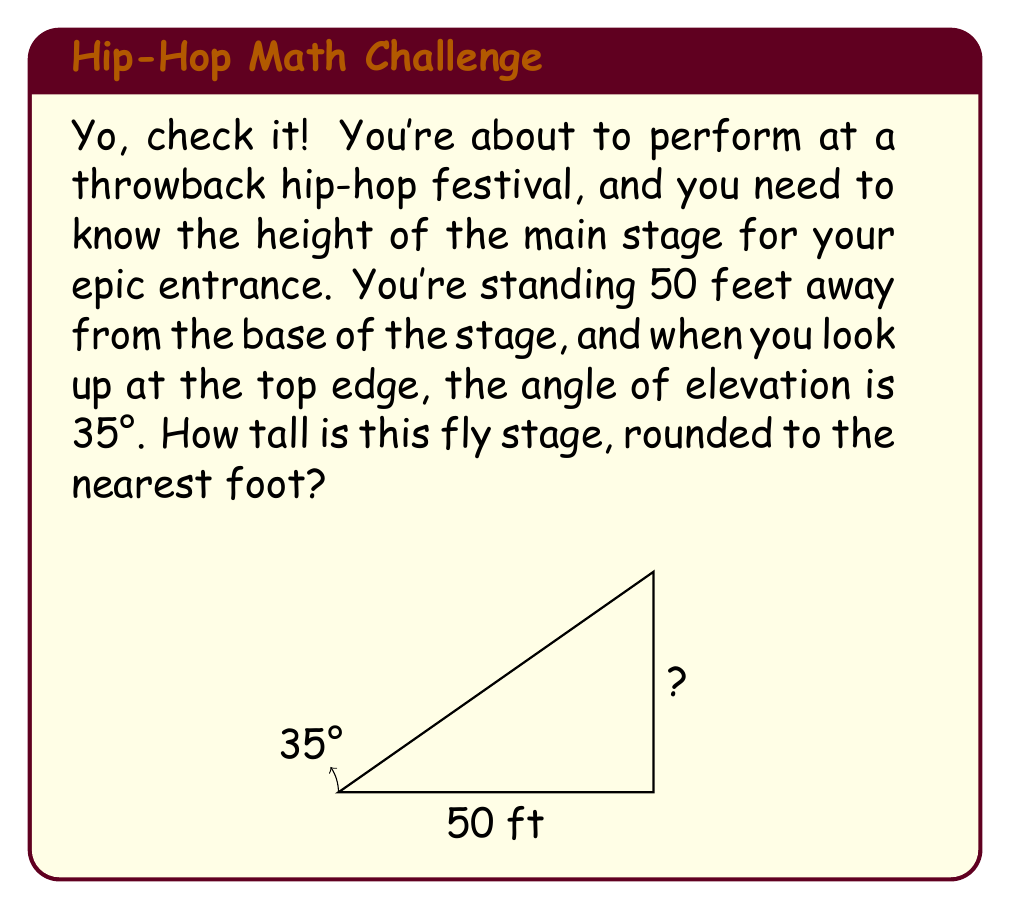Teach me how to tackle this problem. Aight, let's break this down, old school style:

1) We've got a right triangle here, with the stage height as the opposite side and the distance you're standing from the stage as the adjacent side.

2) We're looking for the opposite side (height), and we know the adjacent side (distance) and the angle. This screams tangent ratio!

3) The tangent of an angle in a right triangle is the ratio of the opposite side to the adjacent side. In mathematical terms:

   $$ \tan(\theta) = \frac{\text{opposite}}{\text{adjacent}} $$

4) We can rearrange this to solve for the opposite side:

   $$ \text{opposite} = \text{adjacent} \times \tan(\theta) $$

5) Plugging in our values:
   
   $$ \text{height} = 50 \times \tan(35°) $$

6) Now, let's calculate:
   
   $$ \text{height} = 50 \times 0.7002 = 35.01 \text{ feet} $$

7) Rounding to the nearest foot:

   $$ \text{height} \approx 35 \text{ feet} $$

And there you have it! That stage is as tall as your rhymes are deep!
Answer: 35 feet 